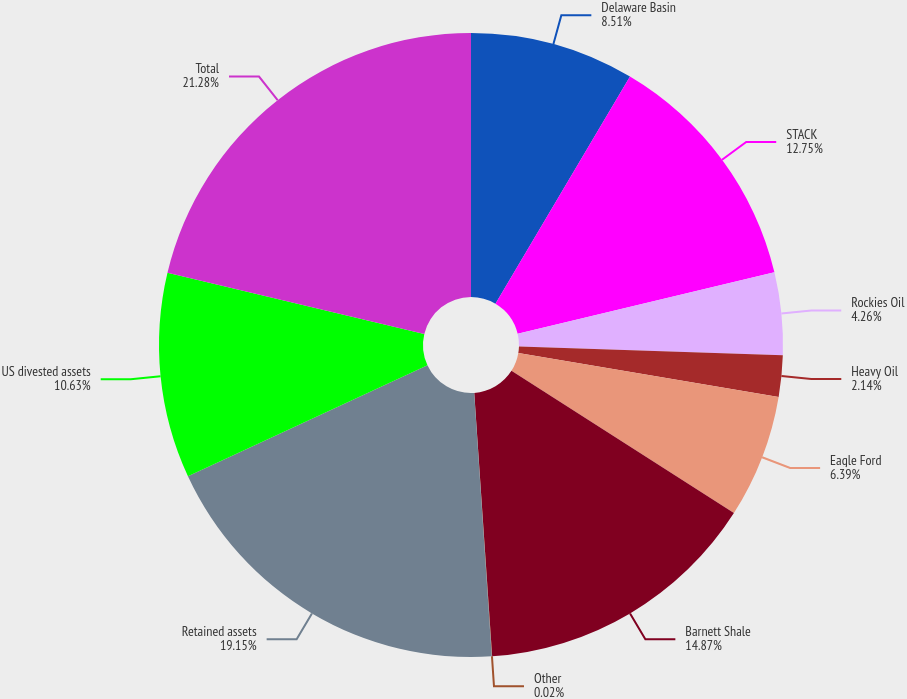Convert chart. <chart><loc_0><loc_0><loc_500><loc_500><pie_chart><fcel>Delaware Basin<fcel>STACK<fcel>Rockies Oil<fcel>Heavy Oil<fcel>Eagle Ford<fcel>Barnett Shale<fcel>Other<fcel>Retained assets<fcel>US divested assets<fcel>Total<nl><fcel>8.51%<fcel>12.75%<fcel>4.26%<fcel>2.14%<fcel>6.39%<fcel>14.87%<fcel>0.02%<fcel>19.15%<fcel>10.63%<fcel>21.28%<nl></chart> 